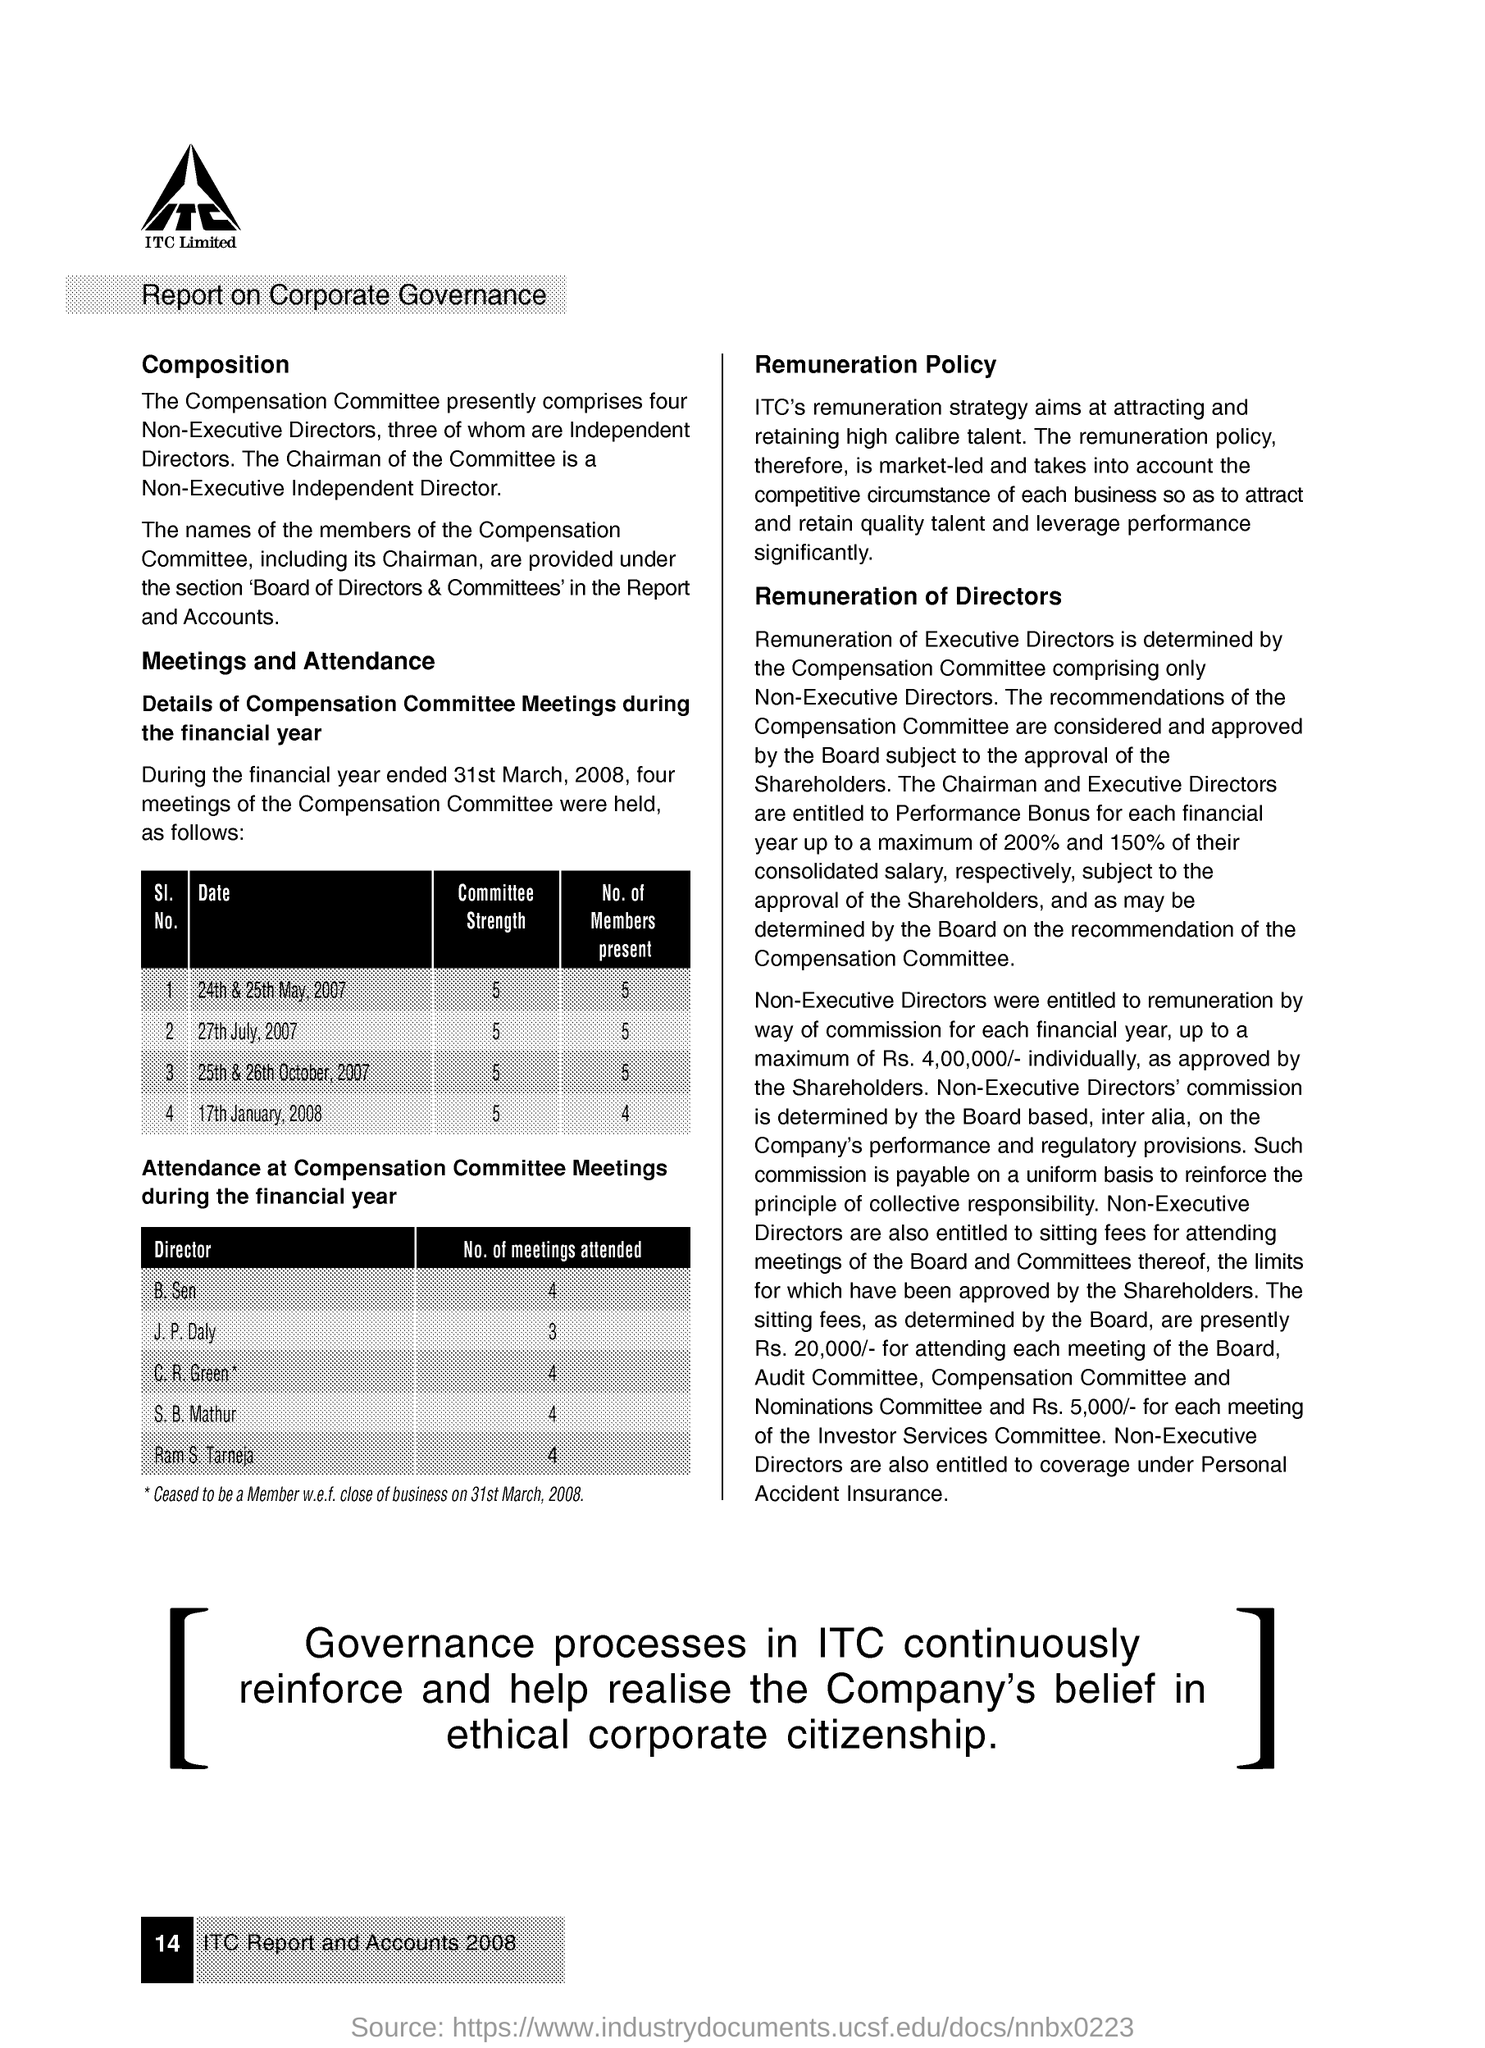What is the number of members present on 17th January 2008?
Your answer should be compact. 4. What is the number of members present on 27th July 2007?
Keep it short and to the point. 5. What is the committee's strength on all the given day?
Your answer should be very brief. 5. What is the number of meetings attended by B. Sen?
Provide a succinct answer. 4. What is the number of meetings attended by J.P. Daly?
Your answer should be compact. 3. What is the number of meetings attended by S.B. Mathur?
Offer a terse response. 4. 